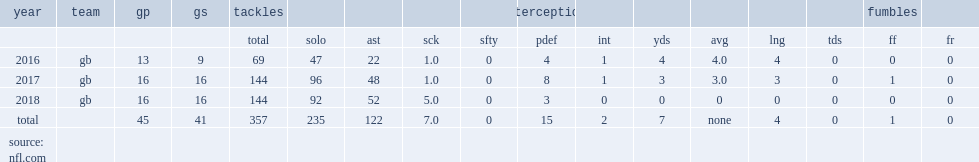How many combined tackles did martinez get in 2017? 144.0. 